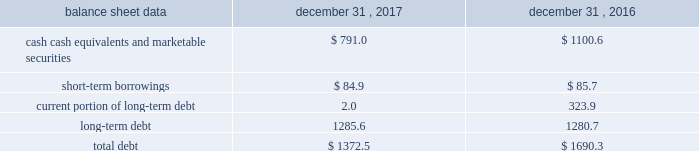Management 2019s discussion and analysis of financial condition and results of operations 2013 ( continued ) ( amounts in millions , except per share amounts ) the effect of foreign exchange rate changes on cash , cash equivalents and restricted cash included in the consolidated statements of cash flows resulted in an increase of $ 11.6 in 2016 , primarily a result of the brazilian real strengthening against the u.s .
Dollar as of december 31 , 2016 compared to december 31 , 2015. .
Liquidity outlook we expect our cash flow from operations and existing cash and cash equivalents to be sufficient to meet our anticipated operating requirements at a minimum for the next twelve months .
We also have a committed corporate credit facility , uncommitted lines of credit and a commercial paper program available to support our operating needs .
We continue to maintain a disciplined approach to managing liquidity , with flexibility over significant uses of cash , including our capital expenditures , cash used for new acquisitions , our common stock repurchase program and our common stock dividends .
From time to time , we evaluate market conditions and financing alternatives for opportunities to raise additional funds or otherwise improve our liquidity profile , enhance our financial flexibility and manage market risk .
Our ability to access the capital markets depends on a number of factors , which include those specific to us , such as our credit ratings , and those related to the financial markets , such as the amount or terms of available credit .
There can be no guarantee that we would be able to access new sources of liquidity , or continue to access existing sources of liquidity , on commercially reasonable terms , or at all .
Funding requirements our most significant funding requirements include our operations , non-cancelable operating lease obligations , capital expenditures , acquisitions , common stock dividends , taxes and debt service .
Additionally , we may be required to make payments to minority shareholders in certain subsidiaries if they exercise their options to sell us their equity interests .
Notable funding requirements include : 2022 debt service 2013 as of december 31 , 2017 , we had outstanding short-term borrowings of $ 84.9 from our uncommitted lines of credit used primarily to fund seasonal working capital needs .
The remainder of our debt is primarily long-term , with maturities scheduled through 2024 .
See the table below for the maturity schedule of our long-term debt .
2022 acquisitions 2013 we paid cash of $ 29.7 , net of cash acquired of $ 7.1 , for acquisitions completed in 2017 .
We also paid $ 0.9 in up-front payments and $ 100.8 in deferred payments for prior-year acquisitions as well as ownership increases in our consolidated subsidiaries .
In addition to potential cash expenditures for new acquisitions , we expect to pay approximately $ 42.0 in 2018 related to prior acquisitions .
We may also be required to pay approximately $ 33.0 in 2018 related to put options held by minority shareholders if exercised .
We will continue to evaluate strategic opportunities to grow and continue to strengthen our market position , particularly in our digital and marketing services offerings , and to expand our presence in high-growth and key strategic world markets .
2022 dividends 2013 during 2017 , we paid four quarterly cash dividends of $ 0.18 per share on our common stock , which corresponded to aggregate dividend payments of $ 280.3 .
On february 14 , 2018 , we announced that our board of directors ( the 201cboard 201d ) had declared a common stock cash dividend of $ 0.21 per share , payable on march 15 , 2018 to holders of record as of the close of business on march 1 , 2018 .
Assuming we pay a quarterly dividend of $ 0.21 per share and there is no significant change in the number of outstanding shares as of december 31 , 2017 , we would expect to pay approximately $ 320.0 over the next twelve months. .
What is the percentage decrease in cash equivalent and marketable securities from 2016-2017? 
Computations: (((1100.6 - 791.0) / 1100.6) * 100)
Answer: 28.13011. 